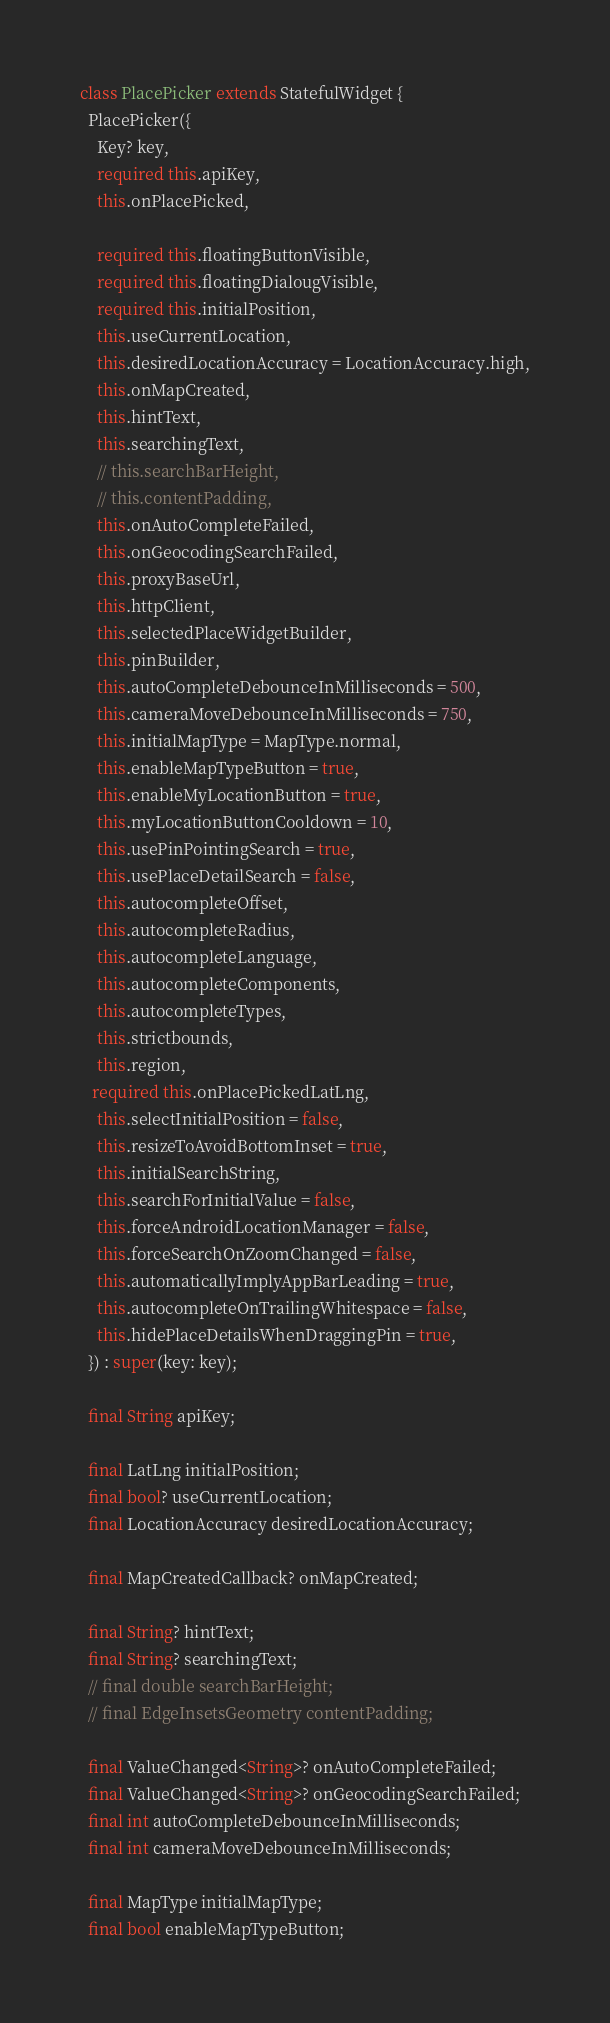Convert code to text. <code><loc_0><loc_0><loc_500><loc_500><_Dart_>
class PlacePicker extends StatefulWidget {
  PlacePicker({
    Key? key,
    required this.apiKey,
    this.onPlacePicked,

    required this.floatingButtonVisible,
    required this.floatingDialougVisible,
    required this.initialPosition,
    this.useCurrentLocation,
    this.desiredLocationAccuracy = LocationAccuracy.high,
    this.onMapCreated,
    this.hintText,
    this.searchingText,
    // this.searchBarHeight,
    // this.contentPadding,
    this.onAutoCompleteFailed,
    this.onGeocodingSearchFailed,
    this.proxyBaseUrl,
    this.httpClient,
    this.selectedPlaceWidgetBuilder,
    this.pinBuilder,
    this.autoCompleteDebounceInMilliseconds = 500,
    this.cameraMoveDebounceInMilliseconds = 750,
    this.initialMapType = MapType.normal,
    this.enableMapTypeButton = true,
    this.enableMyLocationButton = true,
    this.myLocationButtonCooldown = 10,
    this.usePinPointingSearch = true,
    this.usePlaceDetailSearch = false,
    this.autocompleteOffset,
    this.autocompleteRadius,
    this.autocompleteLanguage,
    this.autocompleteComponents,
    this.autocompleteTypes,
    this.strictbounds,
    this.region,
   required this.onPlacePickedLatLng,
    this.selectInitialPosition = false,
    this.resizeToAvoidBottomInset = true,
    this.initialSearchString,
    this.searchForInitialValue = false,
    this.forceAndroidLocationManager = false,
    this.forceSearchOnZoomChanged = false,
    this.automaticallyImplyAppBarLeading = true,
    this.autocompleteOnTrailingWhitespace = false,
    this.hidePlaceDetailsWhenDraggingPin = true,
  }) : super(key: key);

  final String apiKey;

  final LatLng initialPosition;
  final bool? useCurrentLocation;
  final LocationAccuracy desiredLocationAccuracy;

  final MapCreatedCallback? onMapCreated;

  final String? hintText;
  final String? searchingText;
  // final double searchBarHeight;
  // final EdgeInsetsGeometry contentPadding;

  final ValueChanged<String>? onAutoCompleteFailed;
  final ValueChanged<String>? onGeocodingSearchFailed;
  final int autoCompleteDebounceInMilliseconds;
  final int cameraMoveDebounceInMilliseconds;

  final MapType initialMapType;
  final bool enableMapTypeButton;</code> 